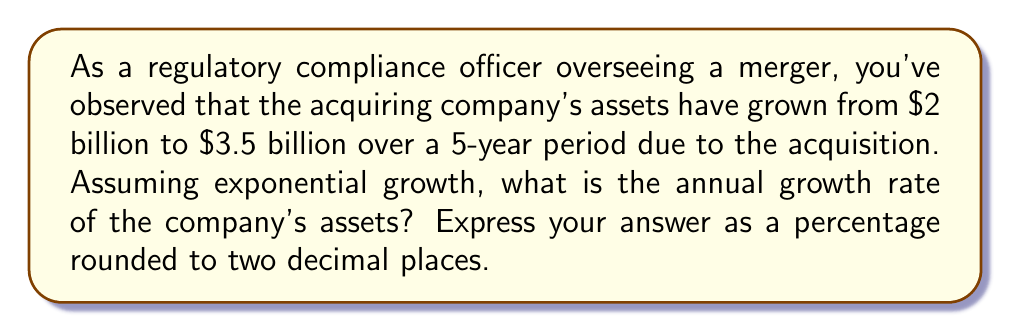Can you answer this question? To solve this problem, we'll use the exponential growth formula:

$$A = P(1 + r)^t$$

Where:
$A$ = Final amount
$P$ = Initial principal balance
$r$ = Annual growth rate (in decimal form)
$t$ = Time period (in years)

Given:
$P = 2$ billion
$A = 3.5$ billion
$t = 5$ years

Step 1: Plug the known values into the formula:
$$3.5 = 2(1 + r)^5$$

Step 2: Divide both sides by 2:
$$1.75 = (1 + r)^5$$

Step 3: Take the 5th root of both sides:
$$\sqrt[5]{1.75} = 1 + r$$

Step 4: Subtract 1 from both sides:
$$\sqrt[5]{1.75} - 1 = r$$

Step 5: Calculate the value:
$$r \approx 0.11834$$

Step 6: Convert to a percentage:
$$r \approx 11.834\%$$

Step 7: Round to two decimal places:
$$r \approx 11.83\%$$
Answer: The annual growth rate of the company's assets is approximately 11.83%. 